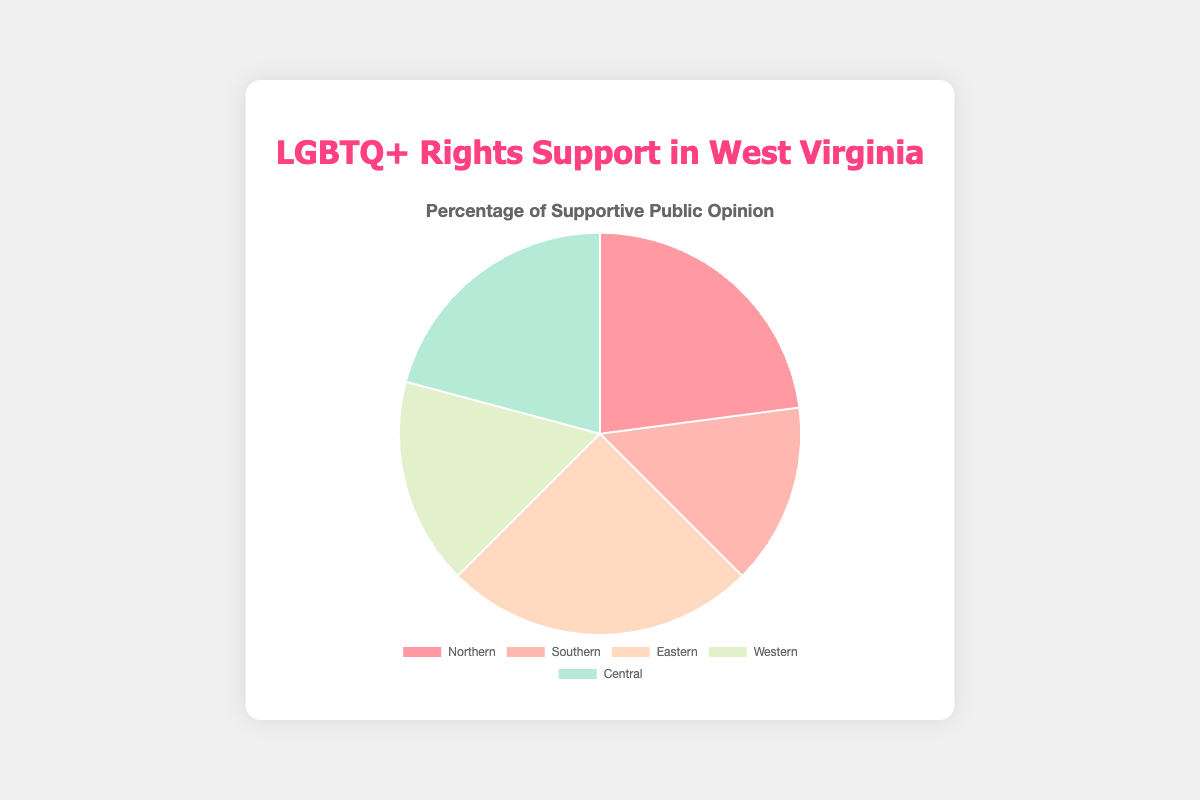Which region has the highest percentage of supportive opinions on LGBTQ+ rights? The figure shows that Eastern West Virginia has the highest percentage of supportive opinions with 60%.
Answer: Eastern West Virginia Which region has the lowest percentage of supportive opinions on LGBTQ+ rights? The figure indicates that Southern West Virginia has the lowest percentage of supportive opinions at 35%.
Answer: Southern West Virginia What is the difference in supportive opinions between Northern and Southern West Virginia? Northern West Virginia has a supportive percentage of 55%, while Southern West Virginia has 35%. The difference is 55% - 35% = 20%.
Answer: 20% Which regions have exactly 30% opposed opinions on LGBTQ+ rights? The figure shows that both Western and Central West Virginia have exactly 30% opposed opinions.
Answer: Western and Central West Virginia What is the average percentage of supportive opinions across all the regions? The supportive opinions percentages are 55%, 35%, 60%, 40%, and 50%. Adding them gives 55 + 35 + 60 + 40 + 50 = 240. The average is 240 / 5 = 48%.
Answer: 48% Which region has the most balanced public opinion (i.e., the smallest difference between supportive and opposed opinions)? Western West Virginia has 40% supportive and 30% opposed opinions, making the difference 10%, which is the smallest compared to other regions.
Answer: Western West Virginia What is the total percentage of neutral opinions in Northern and Central West Virginia combined? Northern West Virginia has 20% neutral opinions and Central West Virginia has 20%. The total is 20% + 20% = 40%.
Answer: 40% How much more supportive is Eastern West Virginia compared to Western West Virginia? Eastern West Virginia has 60% supportive opinions while Western West Virginia has 40%. The difference is 60% - 40% = 20%.
Answer: 20% Which region has the most varied public opinion, considering the range between the highest and lowest percentages of supportive, neutral, and opposed opinions? Southern West Virginia has the most varied opinion with supportive at 35%, neutral at 25%, and opposed at 40%. The range is 40% - 25% = 15%.
Answer: Southern West Virginia 